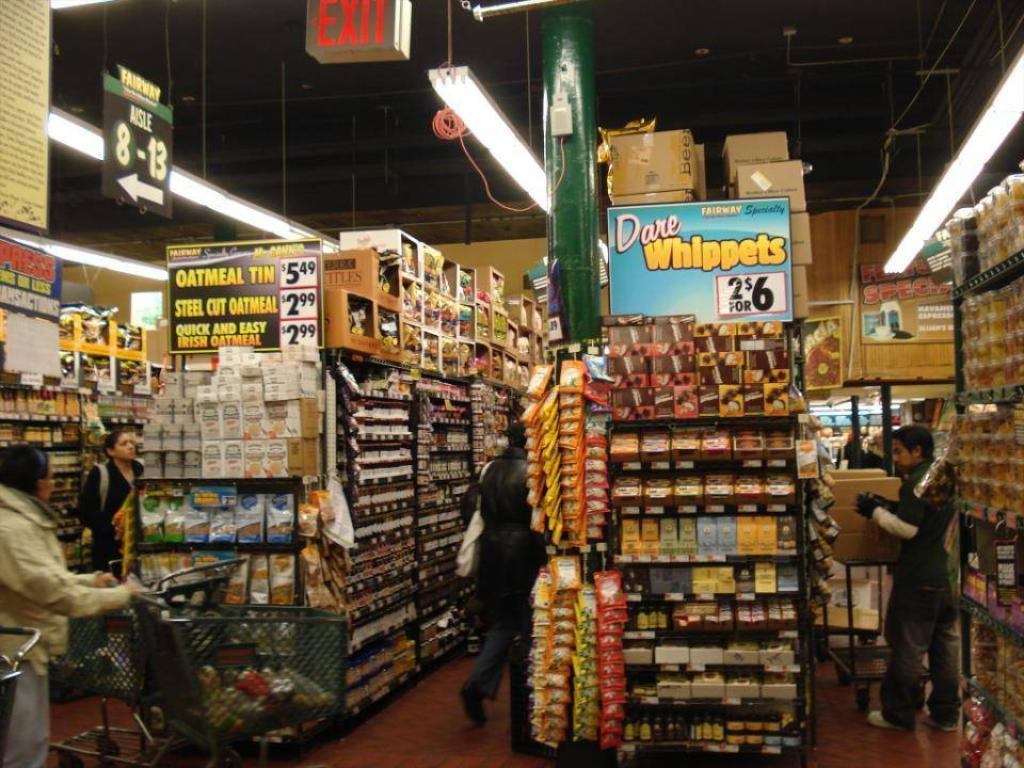What can be seen inside the shop in the image? There are persons in the shop. What is on the shelves in the shop? There are items on the shelves. What helps to illuminate the shop? There are lights in the shop. What is hanging from the roof in the shop? There are boards hanging from the roof. What religious symbols can be seen in the shop? There is no mention of any religious symbols in the image, so we cannot determine if any are present. Is there a swing inside the shop? There is no mention of a swing in the image, so we cannot determine if one is present. 